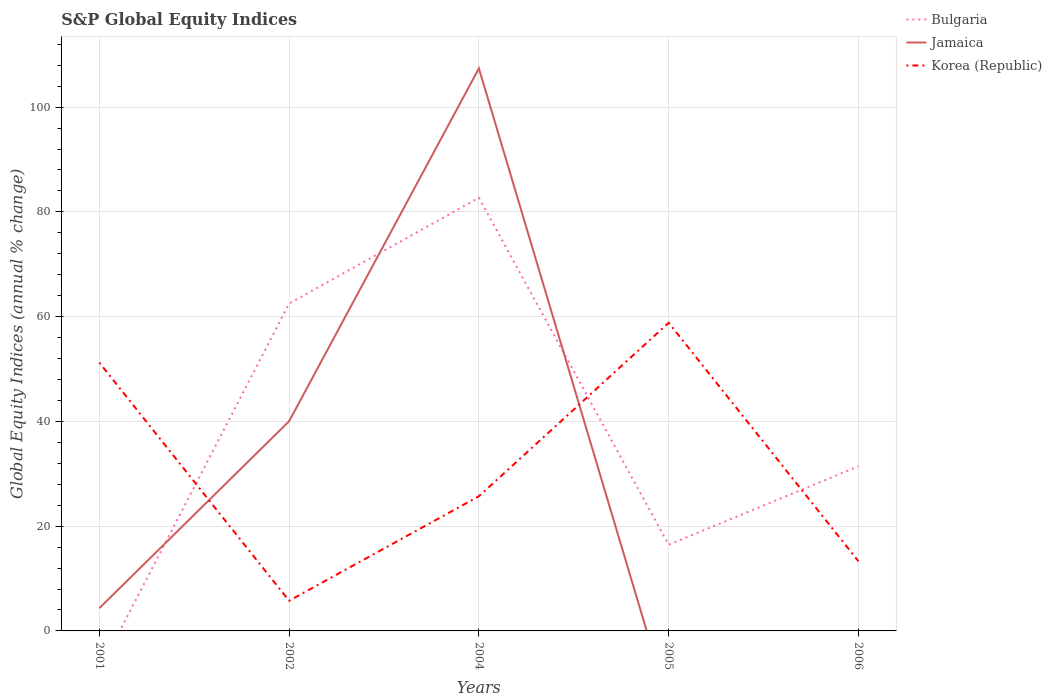How many different coloured lines are there?
Your response must be concise. 3. Does the line corresponding to Jamaica intersect with the line corresponding to Korea (Republic)?
Your answer should be compact. Yes. Is the number of lines equal to the number of legend labels?
Keep it short and to the point. No. Across all years, what is the maximum global equity indices in Korea (Republic)?
Your answer should be compact. 5.76. What is the total global equity indices in Korea (Republic) in the graph?
Make the answer very short. 45.53. What is the difference between the highest and the second highest global equity indices in Jamaica?
Provide a short and direct response. 107.4. What is the difference between the highest and the lowest global equity indices in Bulgaria?
Your answer should be very brief. 2. How many lines are there?
Provide a succinct answer. 3. Are the values on the major ticks of Y-axis written in scientific E-notation?
Your response must be concise. No. Does the graph contain any zero values?
Provide a short and direct response. Yes. Where does the legend appear in the graph?
Offer a terse response. Top right. What is the title of the graph?
Offer a very short reply. S&P Global Equity Indices. What is the label or title of the Y-axis?
Provide a succinct answer. Global Equity Indices (annual % change). What is the Global Equity Indices (annual % change) of Jamaica in 2001?
Your response must be concise. 4.34. What is the Global Equity Indices (annual % change) of Korea (Republic) in 2001?
Give a very brief answer. 51.22. What is the Global Equity Indices (annual % change) in Bulgaria in 2002?
Your answer should be very brief. 62.5. What is the Global Equity Indices (annual % change) in Jamaica in 2002?
Provide a short and direct response. 40.04. What is the Global Equity Indices (annual % change) in Korea (Republic) in 2002?
Provide a succinct answer. 5.76. What is the Global Equity Indices (annual % change) of Bulgaria in 2004?
Provide a short and direct response. 82.7. What is the Global Equity Indices (annual % change) in Jamaica in 2004?
Ensure brevity in your answer.  107.4. What is the Global Equity Indices (annual % change) in Korea (Republic) in 2004?
Provide a short and direct response. 25.71. What is the Global Equity Indices (annual % change) of Bulgaria in 2005?
Keep it short and to the point. 16.45. What is the Global Equity Indices (annual % change) in Jamaica in 2005?
Keep it short and to the point. 0. What is the Global Equity Indices (annual % change) of Korea (Republic) in 2005?
Ensure brevity in your answer.  58.83. What is the Global Equity Indices (annual % change) of Bulgaria in 2006?
Your answer should be compact. 31.44. What is the Global Equity Indices (annual % change) of Jamaica in 2006?
Keep it short and to the point. 0. What is the Global Equity Indices (annual % change) in Korea (Republic) in 2006?
Offer a terse response. 13.3. Across all years, what is the maximum Global Equity Indices (annual % change) in Bulgaria?
Your answer should be very brief. 82.7. Across all years, what is the maximum Global Equity Indices (annual % change) in Jamaica?
Your answer should be very brief. 107.4. Across all years, what is the maximum Global Equity Indices (annual % change) in Korea (Republic)?
Provide a short and direct response. 58.83. Across all years, what is the minimum Global Equity Indices (annual % change) of Jamaica?
Your answer should be very brief. 0. Across all years, what is the minimum Global Equity Indices (annual % change) in Korea (Republic)?
Keep it short and to the point. 5.76. What is the total Global Equity Indices (annual % change) of Bulgaria in the graph?
Make the answer very short. 193.09. What is the total Global Equity Indices (annual % change) in Jamaica in the graph?
Keep it short and to the point. 151.78. What is the total Global Equity Indices (annual % change) in Korea (Republic) in the graph?
Keep it short and to the point. 154.83. What is the difference between the Global Equity Indices (annual % change) of Jamaica in 2001 and that in 2002?
Offer a very short reply. -35.7. What is the difference between the Global Equity Indices (annual % change) of Korea (Republic) in 2001 and that in 2002?
Provide a succinct answer. 45.46. What is the difference between the Global Equity Indices (annual % change) of Jamaica in 2001 and that in 2004?
Ensure brevity in your answer.  -103.06. What is the difference between the Global Equity Indices (annual % change) of Korea (Republic) in 2001 and that in 2004?
Offer a terse response. 25.51. What is the difference between the Global Equity Indices (annual % change) in Korea (Republic) in 2001 and that in 2005?
Provide a succinct answer. -7.61. What is the difference between the Global Equity Indices (annual % change) in Korea (Republic) in 2001 and that in 2006?
Give a very brief answer. 37.92. What is the difference between the Global Equity Indices (annual % change) of Bulgaria in 2002 and that in 2004?
Offer a terse response. -20.2. What is the difference between the Global Equity Indices (annual % change) of Jamaica in 2002 and that in 2004?
Give a very brief answer. -67.36. What is the difference between the Global Equity Indices (annual % change) of Korea (Republic) in 2002 and that in 2004?
Provide a short and direct response. -19.95. What is the difference between the Global Equity Indices (annual % change) of Bulgaria in 2002 and that in 2005?
Make the answer very short. 46.05. What is the difference between the Global Equity Indices (annual % change) of Korea (Republic) in 2002 and that in 2005?
Your answer should be very brief. -53.07. What is the difference between the Global Equity Indices (annual % change) in Bulgaria in 2002 and that in 2006?
Make the answer very short. 31.06. What is the difference between the Global Equity Indices (annual % change) in Korea (Republic) in 2002 and that in 2006?
Offer a terse response. -7.54. What is the difference between the Global Equity Indices (annual % change) of Bulgaria in 2004 and that in 2005?
Offer a very short reply. 66.25. What is the difference between the Global Equity Indices (annual % change) of Korea (Republic) in 2004 and that in 2005?
Ensure brevity in your answer.  -33.12. What is the difference between the Global Equity Indices (annual % change) in Bulgaria in 2004 and that in 2006?
Your answer should be compact. 51.26. What is the difference between the Global Equity Indices (annual % change) of Korea (Republic) in 2004 and that in 2006?
Provide a succinct answer. 12.41. What is the difference between the Global Equity Indices (annual % change) of Bulgaria in 2005 and that in 2006?
Provide a succinct answer. -14.99. What is the difference between the Global Equity Indices (annual % change) in Korea (Republic) in 2005 and that in 2006?
Provide a short and direct response. 45.53. What is the difference between the Global Equity Indices (annual % change) in Jamaica in 2001 and the Global Equity Indices (annual % change) in Korea (Republic) in 2002?
Offer a very short reply. -1.42. What is the difference between the Global Equity Indices (annual % change) of Jamaica in 2001 and the Global Equity Indices (annual % change) of Korea (Republic) in 2004?
Offer a very short reply. -21.37. What is the difference between the Global Equity Indices (annual % change) of Jamaica in 2001 and the Global Equity Indices (annual % change) of Korea (Republic) in 2005?
Your answer should be compact. -54.49. What is the difference between the Global Equity Indices (annual % change) of Jamaica in 2001 and the Global Equity Indices (annual % change) of Korea (Republic) in 2006?
Give a very brief answer. -8.96. What is the difference between the Global Equity Indices (annual % change) in Bulgaria in 2002 and the Global Equity Indices (annual % change) in Jamaica in 2004?
Your response must be concise. -44.9. What is the difference between the Global Equity Indices (annual % change) of Bulgaria in 2002 and the Global Equity Indices (annual % change) of Korea (Republic) in 2004?
Keep it short and to the point. 36.79. What is the difference between the Global Equity Indices (annual % change) of Jamaica in 2002 and the Global Equity Indices (annual % change) of Korea (Republic) in 2004?
Keep it short and to the point. 14.33. What is the difference between the Global Equity Indices (annual % change) in Bulgaria in 2002 and the Global Equity Indices (annual % change) in Korea (Republic) in 2005?
Your response must be concise. 3.67. What is the difference between the Global Equity Indices (annual % change) of Jamaica in 2002 and the Global Equity Indices (annual % change) of Korea (Republic) in 2005?
Provide a short and direct response. -18.79. What is the difference between the Global Equity Indices (annual % change) of Bulgaria in 2002 and the Global Equity Indices (annual % change) of Korea (Republic) in 2006?
Provide a short and direct response. 49.2. What is the difference between the Global Equity Indices (annual % change) of Jamaica in 2002 and the Global Equity Indices (annual % change) of Korea (Republic) in 2006?
Provide a short and direct response. 26.74. What is the difference between the Global Equity Indices (annual % change) of Bulgaria in 2004 and the Global Equity Indices (annual % change) of Korea (Republic) in 2005?
Your answer should be compact. 23.87. What is the difference between the Global Equity Indices (annual % change) of Jamaica in 2004 and the Global Equity Indices (annual % change) of Korea (Republic) in 2005?
Your answer should be very brief. 48.57. What is the difference between the Global Equity Indices (annual % change) in Bulgaria in 2004 and the Global Equity Indices (annual % change) in Korea (Republic) in 2006?
Offer a very short reply. 69.4. What is the difference between the Global Equity Indices (annual % change) of Jamaica in 2004 and the Global Equity Indices (annual % change) of Korea (Republic) in 2006?
Give a very brief answer. 94.1. What is the difference between the Global Equity Indices (annual % change) of Bulgaria in 2005 and the Global Equity Indices (annual % change) of Korea (Republic) in 2006?
Offer a terse response. 3.15. What is the average Global Equity Indices (annual % change) of Bulgaria per year?
Your answer should be compact. 38.62. What is the average Global Equity Indices (annual % change) of Jamaica per year?
Your answer should be compact. 30.36. What is the average Global Equity Indices (annual % change) in Korea (Republic) per year?
Keep it short and to the point. 30.97. In the year 2001, what is the difference between the Global Equity Indices (annual % change) in Jamaica and Global Equity Indices (annual % change) in Korea (Republic)?
Give a very brief answer. -46.88. In the year 2002, what is the difference between the Global Equity Indices (annual % change) in Bulgaria and Global Equity Indices (annual % change) in Jamaica?
Your answer should be very brief. 22.46. In the year 2002, what is the difference between the Global Equity Indices (annual % change) in Bulgaria and Global Equity Indices (annual % change) in Korea (Republic)?
Offer a very short reply. 56.74. In the year 2002, what is the difference between the Global Equity Indices (annual % change) of Jamaica and Global Equity Indices (annual % change) of Korea (Republic)?
Ensure brevity in your answer.  34.28. In the year 2004, what is the difference between the Global Equity Indices (annual % change) of Bulgaria and Global Equity Indices (annual % change) of Jamaica?
Make the answer very short. -24.7. In the year 2004, what is the difference between the Global Equity Indices (annual % change) of Bulgaria and Global Equity Indices (annual % change) of Korea (Republic)?
Offer a terse response. 56.99. In the year 2004, what is the difference between the Global Equity Indices (annual % change) of Jamaica and Global Equity Indices (annual % change) of Korea (Republic)?
Ensure brevity in your answer.  81.69. In the year 2005, what is the difference between the Global Equity Indices (annual % change) of Bulgaria and Global Equity Indices (annual % change) of Korea (Republic)?
Offer a very short reply. -42.38. In the year 2006, what is the difference between the Global Equity Indices (annual % change) of Bulgaria and Global Equity Indices (annual % change) of Korea (Republic)?
Your answer should be compact. 18.14. What is the ratio of the Global Equity Indices (annual % change) in Jamaica in 2001 to that in 2002?
Offer a terse response. 0.11. What is the ratio of the Global Equity Indices (annual % change) of Korea (Republic) in 2001 to that in 2002?
Give a very brief answer. 8.89. What is the ratio of the Global Equity Indices (annual % change) of Jamaica in 2001 to that in 2004?
Your answer should be compact. 0.04. What is the ratio of the Global Equity Indices (annual % change) of Korea (Republic) in 2001 to that in 2004?
Provide a short and direct response. 1.99. What is the ratio of the Global Equity Indices (annual % change) in Korea (Republic) in 2001 to that in 2005?
Provide a short and direct response. 0.87. What is the ratio of the Global Equity Indices (annual % change) in Korea (Republic) in 2001 to that in 2006?
Provide a succinct answer. 3.85. What is the ratio of the Global Equity Indices (annual % change) of Bulgaria in 2002 to that in 2004?
Ensure brevity in your answer.  0.76. What is the ratio of the Global Equity Indices (annual % change) in Jamaica in 2002 to that in 2004?
Your response must be concise. 0.37. What is the ratio of the Global Equity Indices (annual % change) of Korea (Republic) in 2002 to that in 2004?
Provide a succinct answer. 0.22. What is the ratio of the Global Equity Indices (annual % change) of Bulgaria in 2002 to that in 2005?
Ensure brevity in your answer.  3.8. What is the ratio of the Global Equity Indices (annual % change) of Korea (Republic) in 2002 to that in 2005?
Offer a very short reply. 0.1. What is the ratio of the Global Equity Indices (annual % change) in Bulgaria in 2002 to that in 2006?
Provide a succinct answer. 1.99. What is the ratio of the Global Equity Indices (annual % change) of Korea (Republic) in 2002 to that in 2006?
Ensure brevity in your answer.  0.43. What is the ratio of the Global Equity Indices (annual % change) in Bulgaria in 2004 to that in 2005?
Ensure brevity in your answer.  5.03. What is the ratio of the Global Equity Indices (annual % change) of Korea (Republic) in 2004 to that in 2005?
Offer a terse response. 0.44. What is the ratio of the Global Equity Indices (annual % change) of Bulgaria in 2004 to that in 2006?
Offer a terse response. 2.63. What is the ratio of the Global Equity Indices (annual % change) in Korea (Republic) in 2004 to that in 2006?
Offer a terse response. 1.93. What is the ratio of the Global Equity Indices (annual % change) of Bulgaria in 2005 to that in 2006?
Make the answer very short. 0.52. What is the ratio of the Global Equity Indices (annual % change) in Korea (Republic) in 2005 to that in 2006?
Offer a very short reply. 4.42. What is the difference between the highest and the second highest Global Equity Indices (annual % change) of Bulgaria?
Offer a very short reply. 20.2. What is the difference between the highest and the second highest Global Equity Indices (annual % change) of Jamaica?
Keep it short and to the point. 67.36. What is the difference between the highest and the second highest Global Equity Indices (annual % change) of Korea (Republic)?
Offer a very short reply. 7.61. What is the difference between the highest and the lowest Global Equity Indices (annual % change) of Bulgaria?
Provide a short and direct response. 82.7. What is the difference between the highest and the lowest Global Equity Indices (annual % change) in Jamaica?
Keep it short and to the point. 107.4. What is the difference between the highest and the lowest Global Equity Indices (annual % change) of Korea (Republic)?
Your response must be concise. 53.07. 